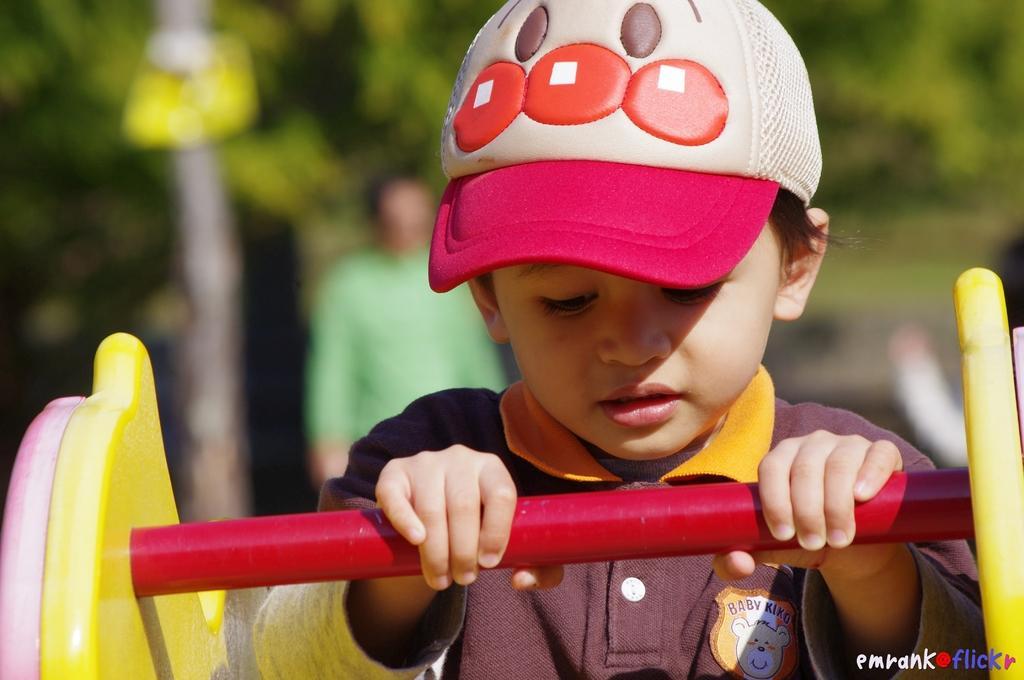Could you give a brief overview of what you see in this image? This image consists of a kid. He is wearing a cap and holding a rod. The background is blurred and we can see the trees and a man. 